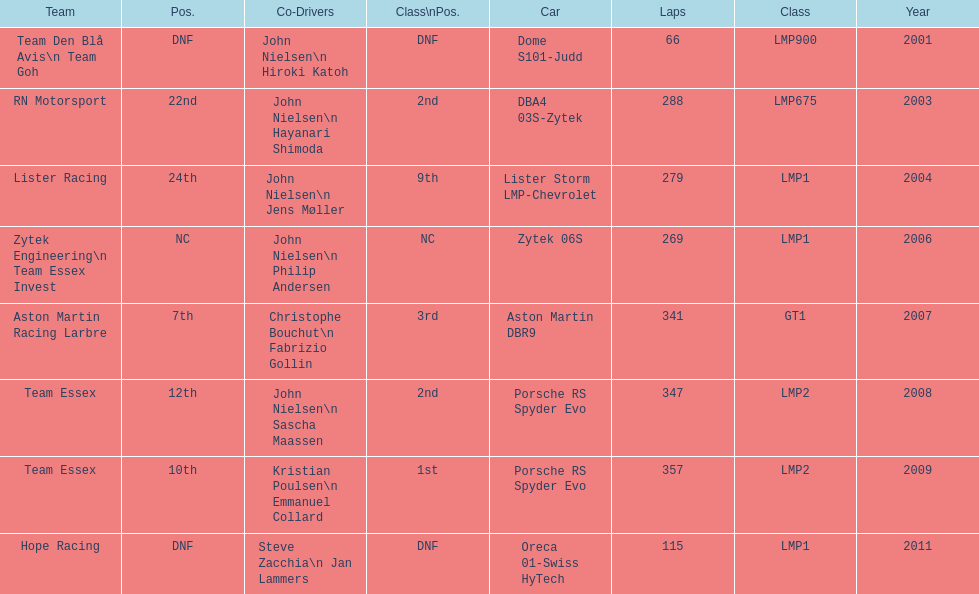Who were the co-drivers for the aston martin dbr9 in 2007? Christophe Bouchut, Fabrizio Gollin. 